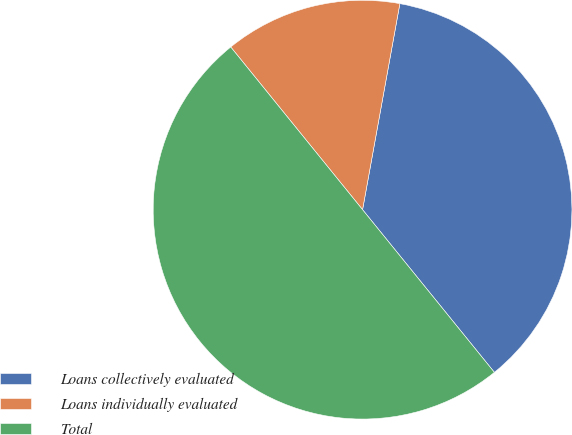Convert chart. <chart><loc_0><loc_0><loc_500><loc_500><pie_chart><fcel>Loans collectively evaluated<fcel>Loans individually evaluated<fcel>Total<nl><fcel>36.31%<fcel>13.69%<fcel>50.0%<nl></chart> 